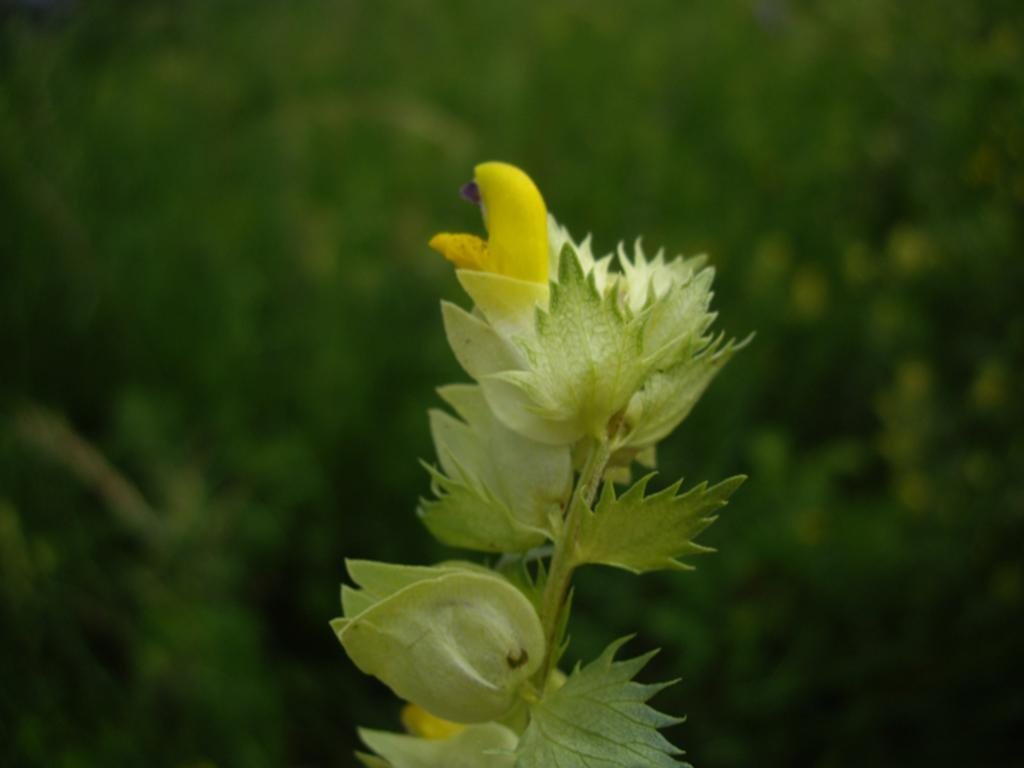What type of plant is visible in the image? There is a plant in the image. What additional features can be seen on the plant? There are flowers in the image. Can you describe the background of the image? The background of the image is blurred. What type of volleyball game is being played in the background of the image? There is no volleyball game present in the image; it features a plant with flowers and a blurred background. What type of destruction can be seen in the image? There is no destruction present in the image; it features a plant with flowers and a blurred background. 